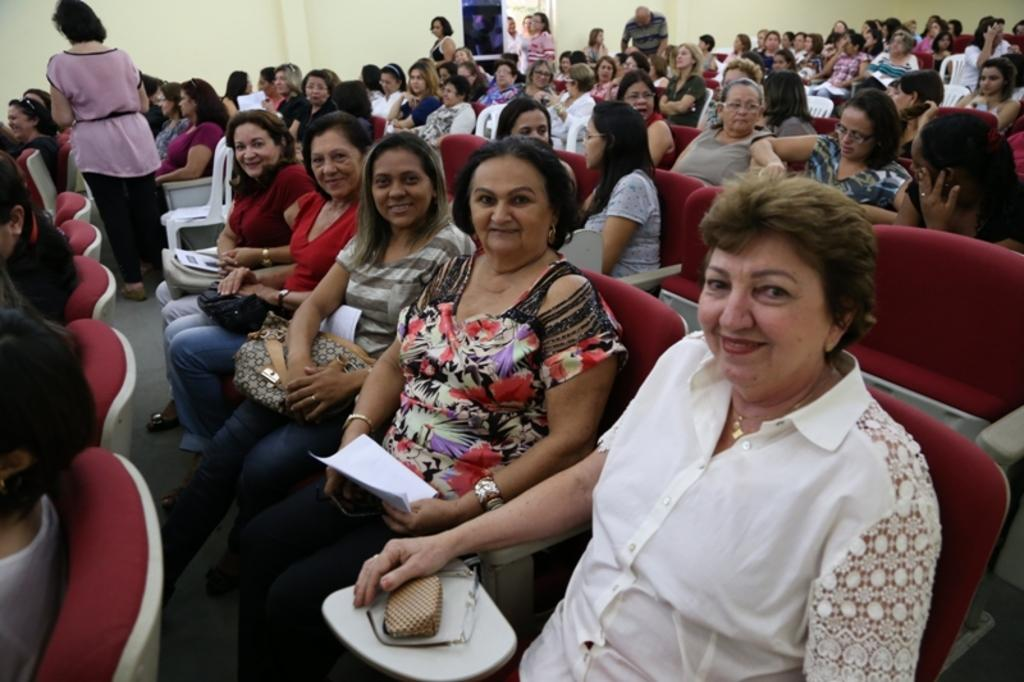What are the people in the image doing? The people in the image are sitting and standing. What are the people wearing? The people are wearing clothes. Can you describe the wall visible in the image? The wall is visible at the top of the image. What type of thrill can be seen on the snail's face in the image? There is no snail present in the image, so it is not possible to determine any emotions or thrill on its face. 